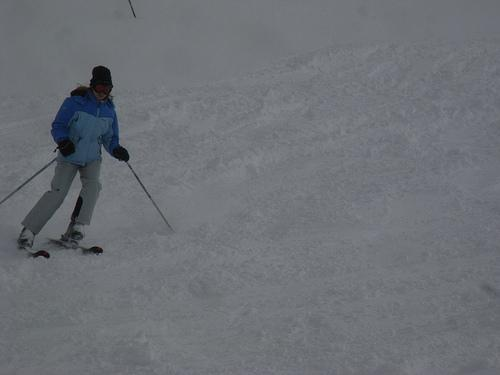Point out the activity the woman is engaged in and the equipment she's holding. The woman is skiing and holding two ski poles in her hands. Mention what the woman is using for her eyes protection and her headwear. The woman is wearing red goggles for eye protection and a black beanie for headwear. Describe the objects that are in contact with the woman's feet and hands. The woman has skis on her feet and is holding ski poles with her hands, which have black gloves on. List the items the woman is wearing and the color of her jacket. The woman is wearing snow boots, a blue coat, black gloves, a black beanie, grey pants, and red goggles. Which tasks can be completed using the given information about the image? Visual Entailment task, Multi-choice VQA task, Product Advertisement task, and Referential Expression Grounding task. What is the color of the woman's jacket, and what is the primary activity she is doing? The woman is wearing a blue jacket and her primary activity is skiing in the snow. What does the woman wear to keep her hands warm, and what colors are the pants? The woman is wearing black gloves to keep her hands warm and grey pants. Using the provided information, describe an advertisement you could create for skiing gear. Picture a confident woman skiing down a mountain of white snow, wearing stylish snow boots, a blue coat, black gloves, a black beanie, and red goggles. Upgrade your skiing experience with our top-notch equipment, including ski poles and durable skis. Be bold, be adventurous, choose our gear! In which setting is the woman skiing, and what is beneath her feet? The woman is skiing in an area covered with white snow, and there are skis under her feet. What is the primary activity happening in the image, and how is the surrounding environment described? A woman is skiing in an area where snow covers the ground and the surrounding environment. 